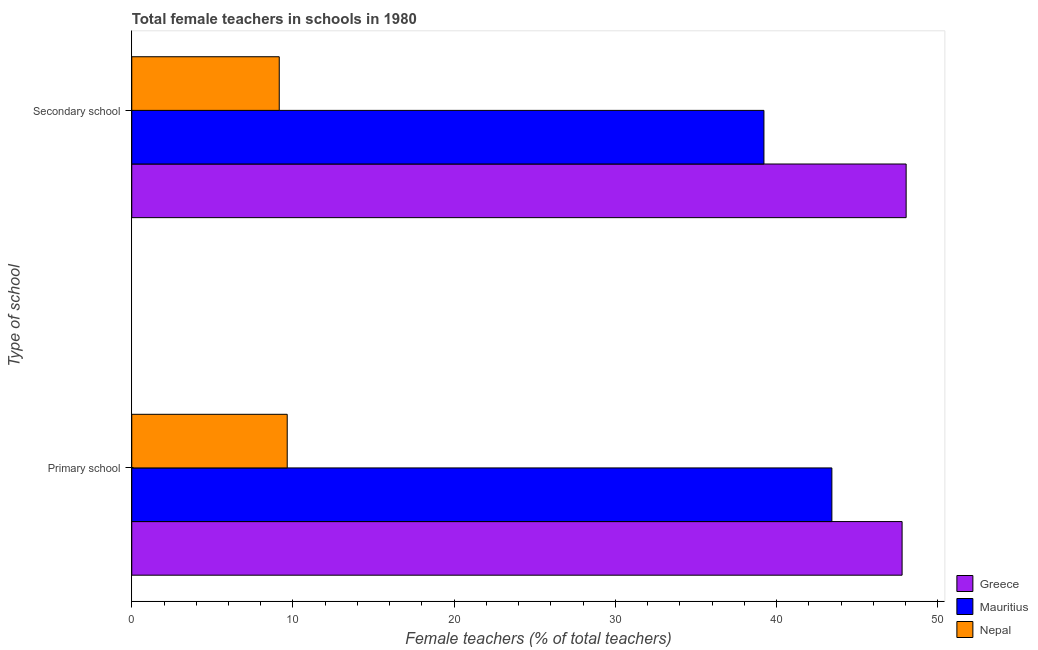Are the number of bars on each tick of the Y-axis equal?
Provide a short and direct response. Yes. How many bars are there on the 2nd tick from the top?
Make the answer very short. 3. What is the label of the 2nd group of bars from the top?
Your response must be concise. Primary school. What is the percentage of female teachers in primary schools in Mauritius?
Ensure brevity in your answer.  43.42. Across all countries, what is the maximum percentage of female teachers in secondary schools?
Make the answer very short. 48.03. Across all countries, what is the minimum percentage of female teachers in secondary schools?
Your answer should be compact. 9.15. In which country was the percentage of female teachers in primary schools maximum?
Offer a very short reply. Greece. In which country was the percentage of female teachers in secondary schools minimum?
Your response must be concise. Nepal. What is the total percentage of female teachers in primary schools in the graph?
Provide a short and direct response. 100.84. What is the difference between the percentage of female teachers in primary schools in Mauritius and that in Nepal?
Make the answer very short. 33.78. What is the difference between the percentage of female teachers in primary schools in Greece and the percentage of female teachers in secondary schools in Nepal?
Offer a terse response. 38.63. What is the average percentage of female teachers in secondary schools per country?
Provide a succinct answer. 32.13. What is the difference between the percentage of female teachers in primary schools and percentage of female teachers in secondary schools in Mauritius?
Your response must be concise. 4.21. In how many countries, is the percentage of female teachers in secondary schools greater than 48 %?
Give a very brief answer. 1. What is the ratio of the percentage of female teachers in secondary schools in Nepal to that in Mauritius?
Keep it short and to the point. 0.23. Is the percentage of female teachers in secondary schools in Greece less than that in Nepal?
Keep it short and to the point. No. In how many countries, is the percentage of female teachers in primary schools greater than the average percentage of female teachers in primary schools taken over all countries?
Ensure brevity in your answer.  2. What does the 3rd bar from the bottom in Primary school represents?
Make the answer very short. Nepal. How many bars are there?
Provide a succinct answer. 6. What is the difference between two consecutive major ticks on the X-axis?
Offer a very short reply. 10. Are the values on the major ticks of X-axis written in scientific E-notation?
Offer a very short reply. No. Does the graph contain any zero values?
Offer a very short reply. No. How many legend labels are there?
Your answer should be compact. 3. What is the title of the graph?
Keep it short and to the point. Total female teachers in schools in 1980. What is the label or title of the X-axis?
Provide a short and direct response. Female teachers (% of total teachers). What is the label or title of the Y-axis?
Your response must be concise. Type of school. What is the Female teachers (% of total teachers) of Greece in Primary school?
Make the answer very short. 47.78. What is the Female teachers (% of total teachers) of Mauritius in Primary school?
Offer a terse response. 43.42. What is the Female teachers (% of total teachers) of Nepal in Primary school?
Your answer should be very brief. 9.64. What is the Female teachers (% of total teachers) in Greece in Secondary school?
Offer a terse response. 48.03. What is the Female teachers (% of total teachers) in Mauritius in Secondary school?
Give a very brief answer. 39.21. What is the Female teachers (% of total teachers) of Nepal in Secondary school?
Ensure brevity in your answer.  9.15. Across all Type of school, what is the maximum Female teachers (% of total teachers) in Greece?
Keep it short and to the point. 48.03. Across all Type of school, what is the maximum Female teachers (% of total teachers) of Mauritius?
Make the answer very short. 43.42. Across all Type of school, what is the maximum Female teachers (% of total teachers) of Nepal?
Ensure brevity in your answer.  9.64. Across all Type of school, what is the minimum Female teachers (% of total teachers) in Greece?
Provide a short and direct response. 47.78. Across all Type of school, what is the minimum Female teachers (% of total teachers) in Mauritius?
Make the answer very short. 39.21. Across all Type of school, what is the minimum Female teachers (% of total teachers) in Nepal?
Keep it short and to the point. 9.15. What is the total Female teachers (% of total teachers) of Greece in the graph?
Provide a succinct answer. 95.81. What is the total Female teachers (% of total teachers) in Mauritius in the graph?
Your response must be concise. 82.63. What is the total Female teachers (% of total teachers) of Nepal in the graph?
Offer a terse response. 18.79. What is the difference between the Female teachers (% of total teachers) in Greece in Primary school and that in Secondary school?
Provide a succinct answer. -0.25. What is the difference between the Female teachers (% of total teachers) of Mauritius in Primary school and that in Secondary school?
Provide a short and direct response. 4.21. What is the difference between the Female teachers (% of total teachers) in Nepal in Primary school and that in Secondary school?
Provide a succinct answer. 0.49. What is the difference between the Female teachers (% of total teachers) in Greece in Primary school and the Female teachers (% of total teachers) in Mauritius in Secondary school?
Your answer should be compact. 8.57. What is the difference between the Female teachers (% of total teachers) in Greece in Primary school and the Female teachers (% of total teachers) in Nepal in Secondary school?
Ensure brevity in your answer.  38.63. What is the difference between the Female teachers (% of total teachers) of Mauritius in Primary school and the Female teachers (% of total teachers) of Nepal in Secondary school?
Make the answer very short. 34.28. What is the average Female teachers (% of total teachers) in Greece per Type of school?
Offer a terse response. 47.9. What is the average Female teachers (% of total teachers) of Mauritius per Type of school?
Your response must be concise. 41.32. What is the average Female teachers (% of total teachers) of Nepal per Type of school?
Offer a very short reply. 9.39. What is the difference between the Female teachers (% of total teachers) of Greece and Female teachers (% of total teachers) of Mauritius in Primary school?
Your answer should be compact. 4.36. What is the difference between the Female teachers (% of total teachers) in Greece and Female teachers (% of total teachers) in Nepal in Primary school?
Ensure brevity in your answer.  38.14. What is the difference between the Female teachers (% of total teachers) of Mauritius and Female teachers (% of total teachers) of Nepal in Primary school?
Keep it short and to the point. 33.78. What is the difference between the Female teachers (% of total teachers) in Greece and Female teachers (% of total teachers) in Mauritius in Secondary school?
Give a very brief answer. 8.82. What is the difference between the Female teachers (% of total teachers) in Greece and Female teachers (% of total teachers) in Nepal in Secondary school?
Ensure brevity in your answer.  38.88. What is the difference between the Female teachers (% of total teachers) in Mauritius and Female teachers (% of total teachers) in Nepal in Secondary school?
Make the answer very short. 30.06. What is the ratio of the Female teachers (% of total teachers) of Greece in Primary school to that in Secondary school?
Your answer should be very brief. 0.99. What is the ratio of the Female teachers (% of total teachers) in Mauritius in Primary school to that in Secondary school?
Your answer should be compact. 1.11. What is the ratio of the Female teachers (% of total teachers) of Nepal in Primary school to that in Secondary school?
Ensure brevity in your answer.  1.05. What is the difference between the highest and the second highest Female teachers (% of total teachers) in Greece?
Provide a succinct answer. 0.25. What is the difference between the highest and the second highest Female teachers (% of total teachers) in Mauritius?
Provide a short and direct response. 4.21. What is the difference between the highest and the second highest Female teachers (% of total teachers) in Nepal?
Provide a short and direct response. 0.49. What is the difference between the highest and the lowest Female teachers (% of total teachers) of Greece?
Keep it short and to the point. 0.25. What is the difference between the highest and the lowest Female teachers (% of total teachers) of Mauritius?
Provide a short and direct response. 4.21. What is the difference between the highest and the lowest Female teachers (% of total teachers) of Nepal?
Your answer should be compact. 0.49. 